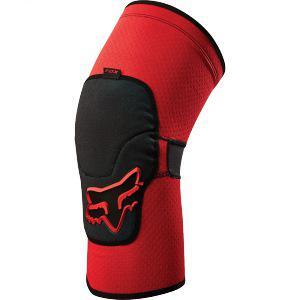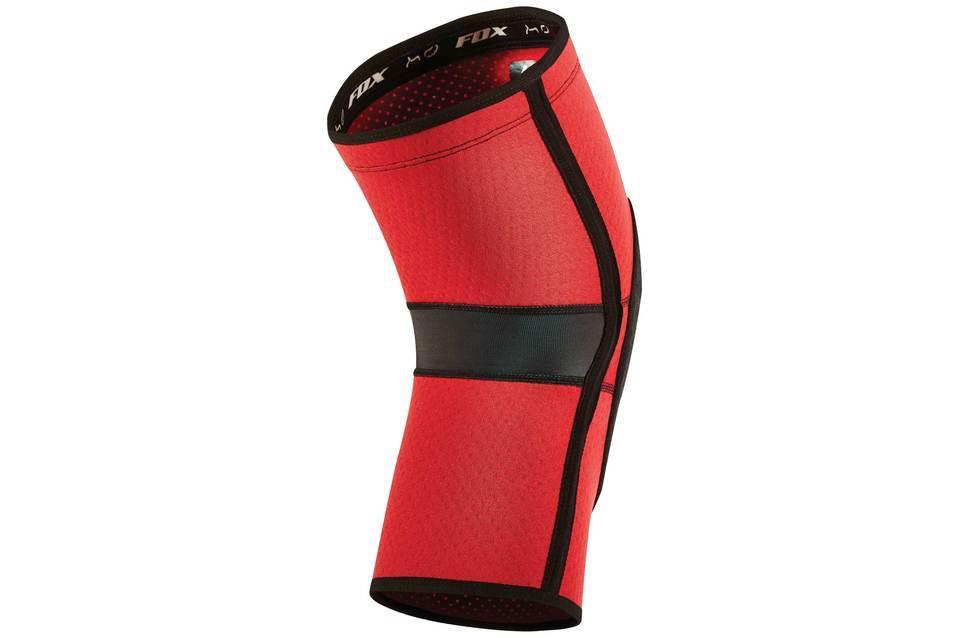The first image is the image on the left, the second image is the image on the right. For the images displayed, is the sentence "There are no less than two knee pads that are red and black in color" factually correct? Answer yes or no. Yes. 